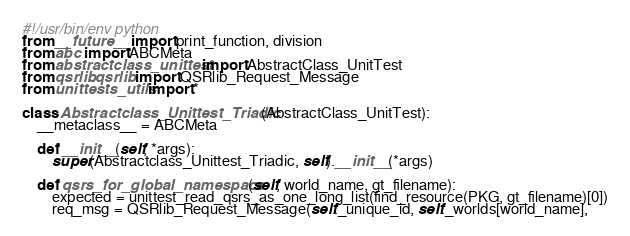Convert code to text. <code><loc_0><loc_0><loc_500><loc_500><_Python_>#!/usr/bin/env python
from __future__ import print_function, division
from abc import ABCMeta
from abstractclass_unittest import AbstractClass_UnitTest
from qsrlib.qsrlib import QSRlib_Request_Message
from unittests_utils import *

class Abstractclass_Unittest_Triadic(AbstractClass_UnitTest):
    __metaclass__ = ABCMeta

    def __init__(self, *args):
        super(Abstractclass_Unittest_Triadic, self).__init__(*args)

    def qsrs_for_global_namespace(self, world_name, gt_filename):
        expected = unittest_read_qsrs_as_one_long_list(find_resource(PKG, gt_filename)[0])
        req_msg = QSRlib_Request_Message(self._unique_id, self._worlds[world_name],</code> 